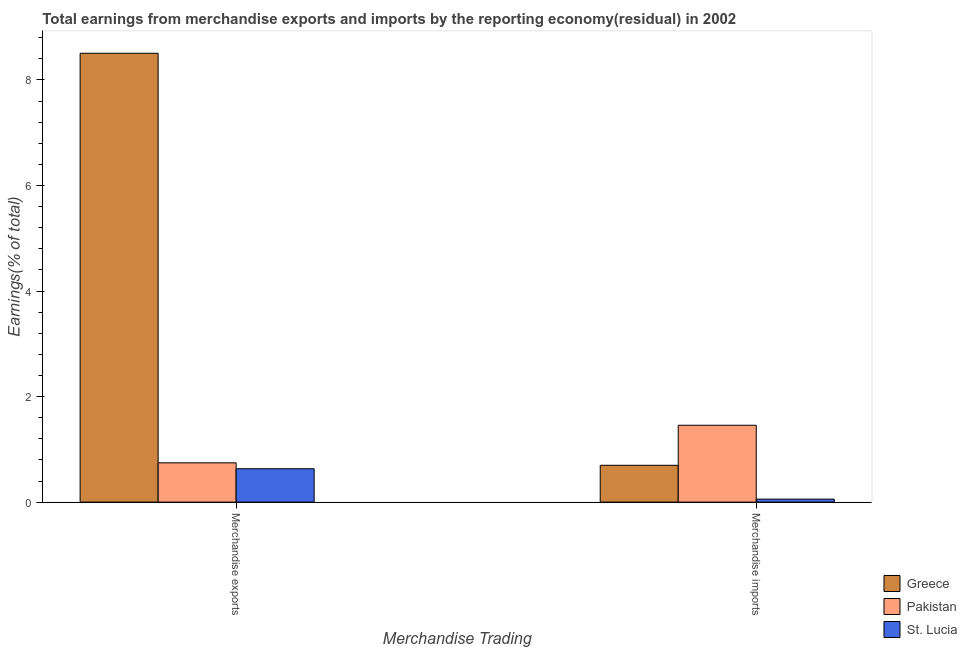How many groups of bars are there?
Keep it short and to the point. 2. Are the number of bars on each tick of the X-axis equal?
Provide a succinct answer. Yes. How many bars are there on the 2nd tick from the right?
Provide a succinct answer. 3. What is the earnings from merchandise imports in Pakistan?
Ensure brevity in your answer.  1.46. Across all countries, what is the maximum earnings from merchandise imports?
Provide a short and direct response. 1.46. Across all countries, what is the minimum earnings from merchandise exports?
Make the answer very short. 0.63. In which country was the earnings from merchandise exports minimum?
Your answer should be very brief. St. Lucia. What is the total earnings from merchandise exports in the graph?
Your response must be concise. 9.88. What is the difference between the earnings from merchandise imports in Greece and that in St. Lucia?
Offer a very short reply. 0.64. What is the difference between the earnings from merchandise exports in Pakistan and the earnings from merchandise imports in Greece?
Provide a short and direct response. 0.05. What is the average earnings from merchandise exports per country?
Provide a short and direct response. 3.29. What is the difference between the earnings from merchandise exports and earnings from merchandise imports in Pakistan?
Offer a terse response. -0.71. In how many countries, is the earnings from merchandise exports greater than 2 %?
Your answer should be compact. 1. What is the ratio of the earnings from merchandise exports in Greece to that in Pakistan?
Ensure brevity in your answer.  11.43. In how many countries, is the earnings from merchandise imports greater than the average earnings from merchandise imports taken over all countries?
Keep it short and to the point. 1. What does the 3rd bar from the right in Merchandise exports represents?
Your answer should be compact. Greece. How many bars are there?
Keep it short and to the point. 6. How many countries are there in the graph?
Offer a terse response. 3. What is the difference between two consecutive major ticks on the Y-axis?
Offer a very short reply. 2. Does the graph contain any zero values?
Your answer should be very brief. No. Does the graph contain grids?
Provide a succinct answer. No. Where does the legend appear in the graph?
Ensure brevity in your answer.  Bottom right. How many legend labels are there?
Provide a succinct answer. 3. How are the legend labels stacked?
Provide a succinct answer. Vertical. What is the title of the graph?
Your response must be concise. Total earnings from merchandise exports and imports by the reporting economy(residual) in 2002. What is the label or title of the X-axis?
Your answer should be compact. Merchandise Trading. What is the label or title of the Y-axis?
Provide a succinct answer. Earnings(% of total). What is the Earnings(% of total) of Greece in Merchandise exports?
Make the answer very short. 8.5. What is the Earnings(% of total) in Pakistan in Merchandise exports?
Keep it short and to the point. 0.74. What is the Earnings(% of total) of St. Lucia in Merchandise exports?
Offer a very short reply. 0.63. What is the Earnings(% of total) of Greece in Merchandise imports?
Ensure brevity in your answer.  0.7. What is the Earnings(% of total) in Pakistan in Merchandise imports?
Your answer should be very brief. 1.46. What is the Earnings(% of total) of St. Lucia in Merchandise imports?
Your answer should be compact. 0.06. Across all Merchandise Trading, what is the maximum Earnings(% of total) of Greece?
Offer a terse response. 8.5. Across all Merchandise Trading, what is the maximum Earnings(% of total) in Pakistan?
Your response must be concise. 1.46. Across all Merchandise Trading, what is the maximum Earnings(% of total) of St. Lucia?
Make the answer very short. 0.63. Across all Merchandise Trading, what is the minimum Earnings(% of total) of Greece?
Give a very brief answer. 0.7. Across all Merchandise Trading, what is the minimum Earnings(% of total) of Pakistan?
Provide a short and direct response. 0.74. Across all Merchandise Trading, what is the minimum Earnings(% of total) of St. Lucia?
Provide a succinct answer. 0.06. What is the total Earnings(% of total) of Greece in the graph?
Make the answer very short. 9.2. What is the total Earnings(% of total) of Pakistan in the graph?
Provide a succinct answer. 2.2. What is the total Earnings(% of total) in St. Lucia in the graph?
Your answer should be compact. 0.69. What is the difference between the Earnings(% of total) in Greece in Merchandise exports and that in Merchandise imports?
Make the answer very short. 7.81. What is the difference between the Earnings(% of total) in Pakistan in Merchandise exports and that in Merchandise imports?
Offer a terse response. -0.71. What is the difference between the Earnings(% of total) in St. Lucia in Merchandise exports and that in Merchandise imports?
Your answer should be compact. 0.58. What is the difference between the Earnings(% of total) of Greece in Merchandise exports and the Earnings(% of total) of Pakistan in Merchandise imports?
Ensure brevity in your answer.  7.05. What is the difference between the Earnings(% of total) in Greece in Merchandise exports and the Earnings(% of total) in St. Lucia in Merchandise imports?
Offer a terse response. 8.45. What is the difference between the Earnings(% of total) in Pakistan in Merchandise exports and the Earnings(% of total) in St. Lucia in Merchandise imports?
Your answer should be very brief. 0.69. What is the average Earnings(% of total) of Greece per Merchandise Trading?
Provide a short and direct response. 4.6. What is the average Earnings(% of total) in Pakistan per Merchandise Trading?
Give a very brief answer. 1.1. What is the average Earnings(% of total) in St. Lucia per Merchandise Trading?
Provide a succinct answer. 0.34. What is the difference between the Earnings(% of total) of Greece and Earnings(% of total) of Pakistan in Merchandise exports?
Your answer should be compact. 7.76. What is the difference between the Earnings(% of total) of Greece and Earnings(% of total) of St. Lucia in Merchandise exports?
Give a very brief answer. 7.87. What is the difference between the Earnings(% of total) of Pakistan and Earnings(% of total) of St. Lucia in Merchandise exports?
Your answer should be very brief. 0.11. What is the difference between the Earnings(% of total) of Greece and Earnings(% of total) of Pakistan in Merchandise imports?
Keep it short and to the point. -0.76. What is the difference between the Earnings(% of total) in Greece and Earnings(% of total) in St. Lucia in Merchandise imports?
Offer a terse response. 0.64. What is the difference between the Earnings(% of total) of Pakistan and Earnings(% of total) of St. Lucia in Merchandise imports?
Make the answer very short. 1.4. What is the ratio of the Earnings(% of total) in Greece in Merchandise exports to that in Merchandise imports?
Your answer should be compact. 12.18. What is the ratio of the Earnings(% of total) in Pakistan in Merchandise exports to that in Merchandise imports?
Offer a very short reply. 0.51. What is the ratio of the Earnings(% of total) in St. Lucia in Merchandise exports to that in Merchandise imports?
Your answer should be very brief. 11.12. What is the difference between the highest and the second highest Earnings(% of total) of Greece?
Offer a terse response. 7.81. What is the difference between the highest and the second highest Earnings(% of total) in Pakistan?
Ensure brevity in your answer.  0.71. What is the difference between the highest and the second highest Earnings(% of total) in St. Lucia?
Ensure brevity in your answer.  0.58. What is the difference between the highest and the lowest Earnings(% of total) in Greece?
Keep it short and to the point. 7.81. What is the difference between the highest and the lowest Earnings(% of total) of Pakistan?
Keep it short and to the point. 0.71. What is the difference between the highest and the lowest Earnings(% of total) of St. Lucia?
Give a very brief answer. 0.58. 